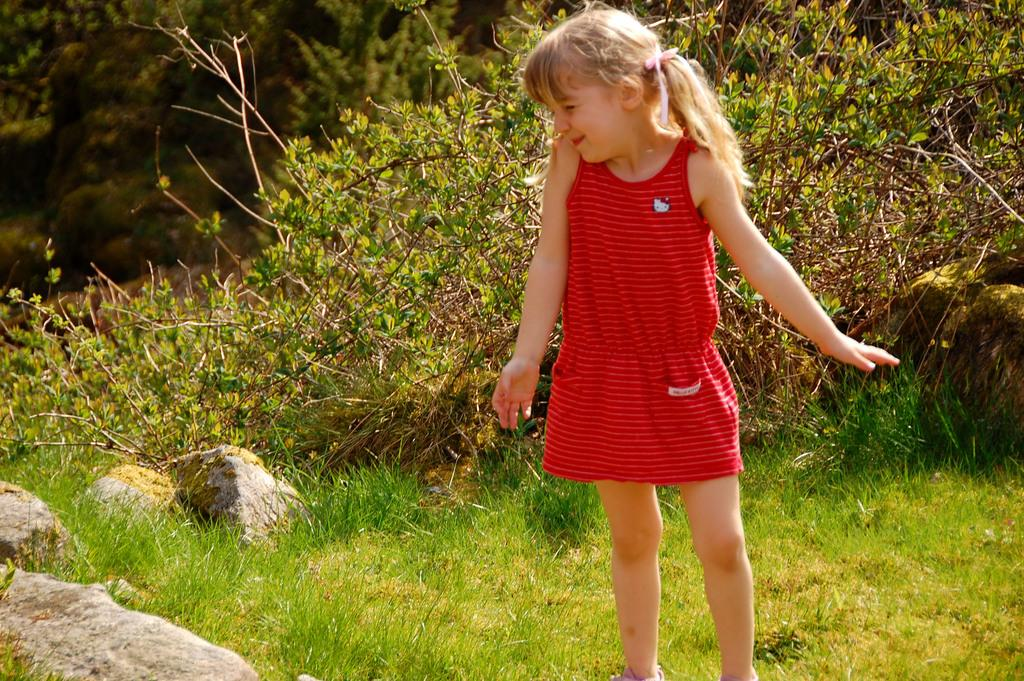Who is the main subject in the image? There is a little girl in the image. What is the girl wearing? The girl is wearing a red dress. What type of vegetation can be seen behind the girl? There are green color trees behind the girl. What is the ground made of in the image? There is grass visible in the image. How many jellyfish can be seen swimming in the grass in the image? There are no jellyfish present in the image, and jellyfish cannot swim in grass. 